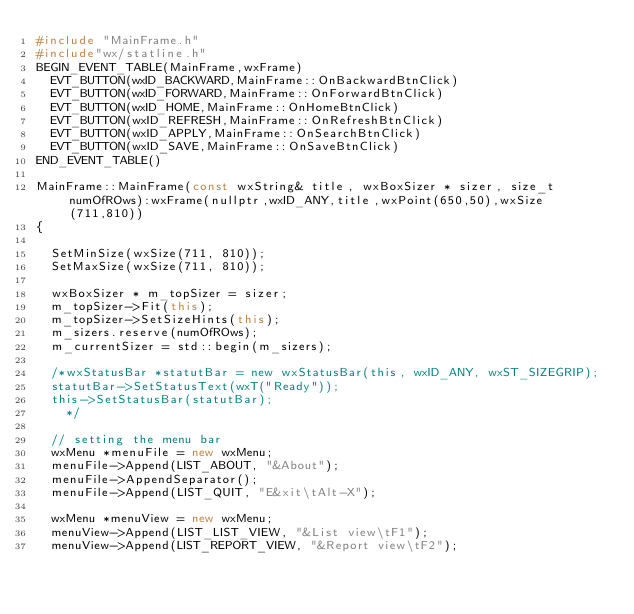Convert code to text. <code><loc_0><loc_0><loc_500><loc_500><_C++_>#include "MainFrame.h"
#include"wx/statline.h"
BEGIN_EVENT_TABLE(MainFrame,wxFrame)
	EVT_BUTTON(wxID_BACKWARD,MainFrame::OnBackwardBtnClick)
	EVT_BUTTON(wxID_FORWARD,MainFrame::OnForwardBtnClick)
	EVT_BUTTON(wxID_HOME,MainFrame::OnHomeBtnClick)
	EVT_BUTTON(wxID_REFRESH,MainFrame::OnRefreshBtnClick)
	EVT_BUTTON(wxID_APPLY,MainFrame::OnSearchBtnClick)
	EVT_BUTTON(wxID_SAVE,MainFrame::OnSaveBtnClick)
END_EVENT_TABLE()

MainFrame::MainFrame(const wxString& title, wxBoxSizer * sizer, size_t numOfROws):wxFrame(nullptr,wxID_ANY,title,wxPoint(650,50),wxSize(711,810))
{
	
	SetMinSize(wxSize(711, 810));
	SetMaxSize(wxSize(711, 810));

	wxBoxSizer * m_topSizer = sizer;
	m_topSizer->Fit(this);
	m_topSizer->SetSizeHints(this);
	m_sizers.reserve(numOfROws);
	m_currentSizer = std::begin(m_sizers);

	/*wxStatusBar *statutBar = new wxStatusBar(this, wxID_ANY, wxST_SIZEGRIP);
	statutBar->SetStatusText(wxT("Ready"));
	this->SetStatusBar(statutBar);
    */

	// setting the menu bar
	wxMenu *menuFile = new wxMenu;
	menuFile->Append(LIST_ABOUT, "&About");
	menuFile->AppendSeparator();
	menuFile->Append(LIST_QUIT, "E&xit\tAlt-X");
	
	wxMenu *menuView = new wxMenu;
	menuView->Append(LIST_LIST_VIEW, "&List view\tF1");
	menuView->Append(LIST_REPORT_VIEW, "&Report view\tF2");
</code> 